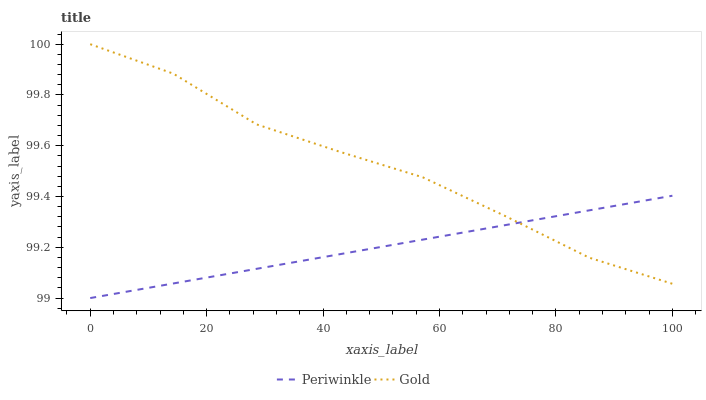Does Periwinkle have the minimum area under the curve?
Answer yes or no. Yes. Does Gold have the maximum area under the curve?
Answer yes or no. Yes. Does Gold have the minimum area under the curve?
Answer yes or no. No. Is Periwinkle the smoothest?
Answer yes or no. Yes. Is Gold the roughest?
Answer yes or no. Yes. Is Gold the smoothest?
Answer yes or no. No. Does Periwinkle have the lowest value?
Answer yes or no. Yes. Does Gold have the lowest value?
Answer yes or no. No. Does Gold have the highest value?
Answer yes or no. Yes. Does Gold intersect Periwinkle?
Answer yes or no. Yes. Is Gold less than Periwinkle?
Answer yes or no. No. Is Gold greater than Periwinkle?
Answer yes or no. No. 